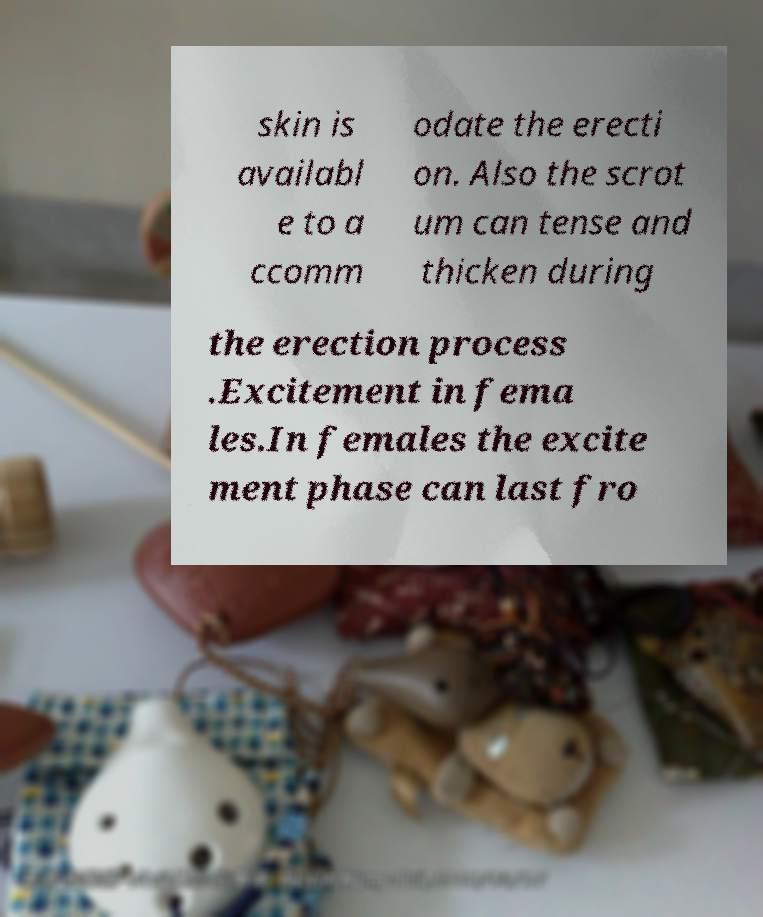For documentation purposes, I need the text within this image transcribed. Could you provide that? skin is availabl e to a ccomm odate the erecti on. Also the scrot um can tense and thicken during the erection process .Excitement in fema les.In females the excite ment phase can last fro 